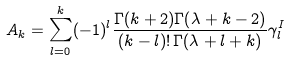<formula> <loc_0><loc_0><loc_500><loc_500>A _ { k } = \sum _ { l = 0 } ^ { k } ( - 1 ) ^ { l } \frac { \Gamma ( k + 2 ) \Gamma ( \lambda + k - 2 ) } { ( k - l ) ! \, \Gamma ( \lambda + l + k ) } \gamma ^ { I } _ { l }</formula> 